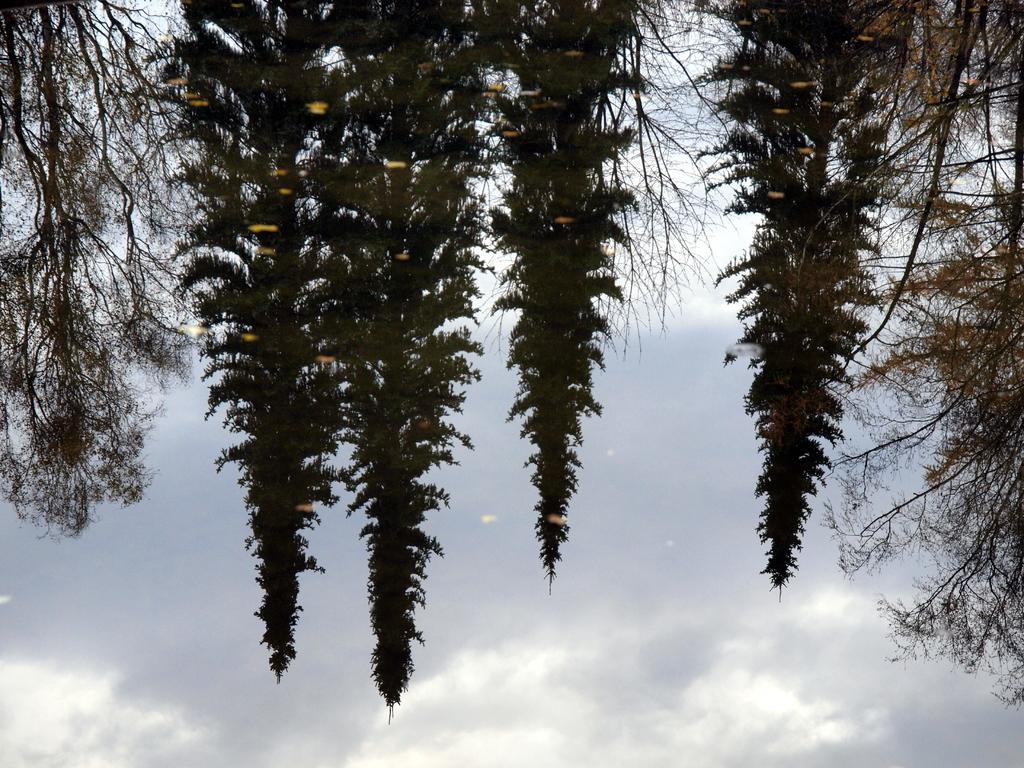What type of vegetation can be seen at the top of the image? There are trees at the top of the image. What is visible in the background of the image? Sky is visible in the background of the image. What can be observed in the sky? Clouds are present in the sky. What type of lace can be seen on the trees in the image? There is no lace present on the trees in the image. Can you tell me how many chess pieces are visible in the image? There are no chess pieces present in the image. 